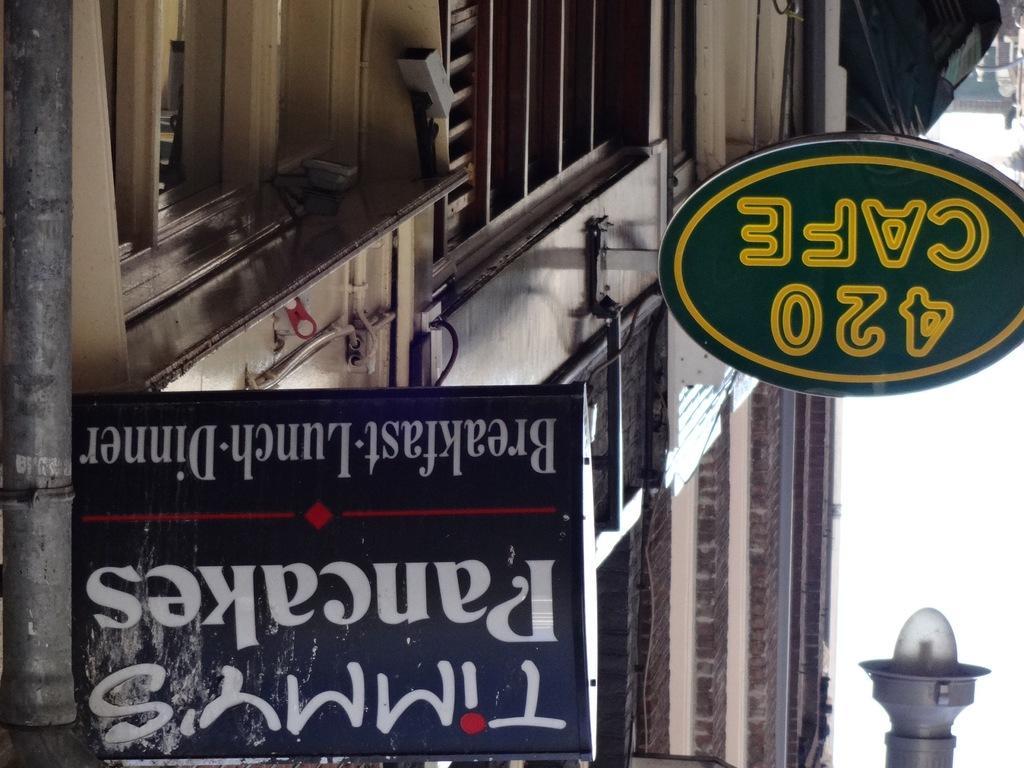Please provide a concise description of this image. This is a rotated image. In this image there is a building and a few boards with some text are attached to it and there is a lamp. 